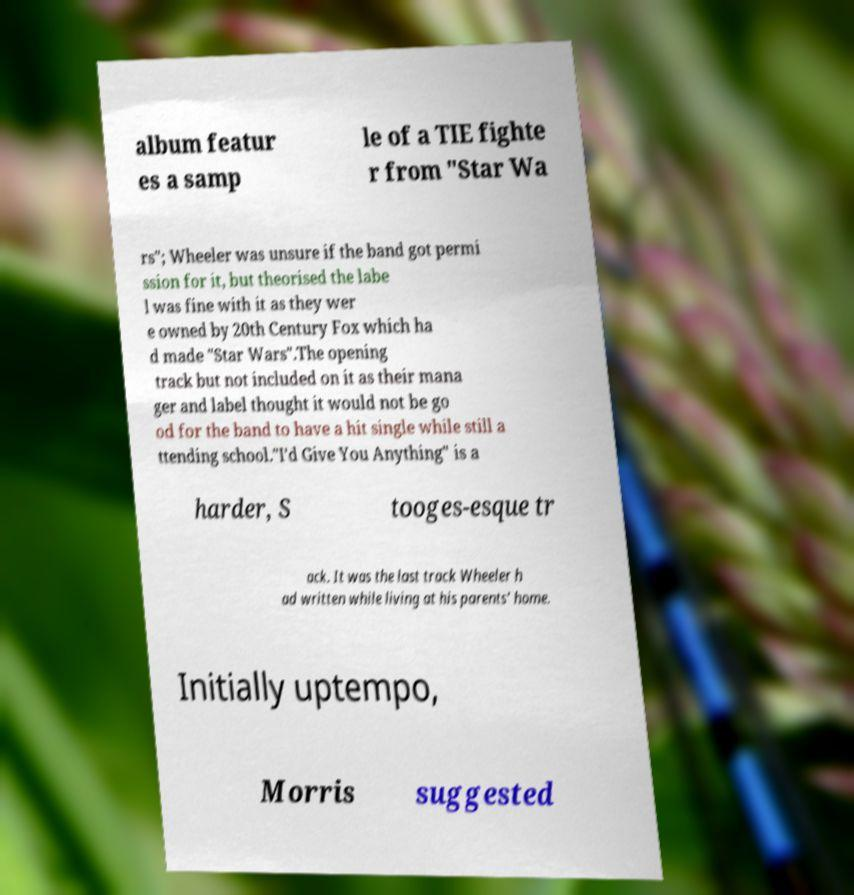For documentation purposes, I need the text within this image transcribed. Could you provide that? album featur es a samp le of a TIE fighte r from "Star Wa rs"; Wheeler was unsure if the band got permi ssion for it, but theorised the labe l was fine with it as they wer e owned by 20th Century Fox which ha d made "Star Wars".The opening track but not included on it as their mana ger and label thought it would not be go od for the band to have a hit single while still a ttending school."I'd Give You Anything" is a harder, S tooges-esque tr ack. It was the last track Wheeler h ad written while living at his parents' home. Initially uptempo, Morris suggested 